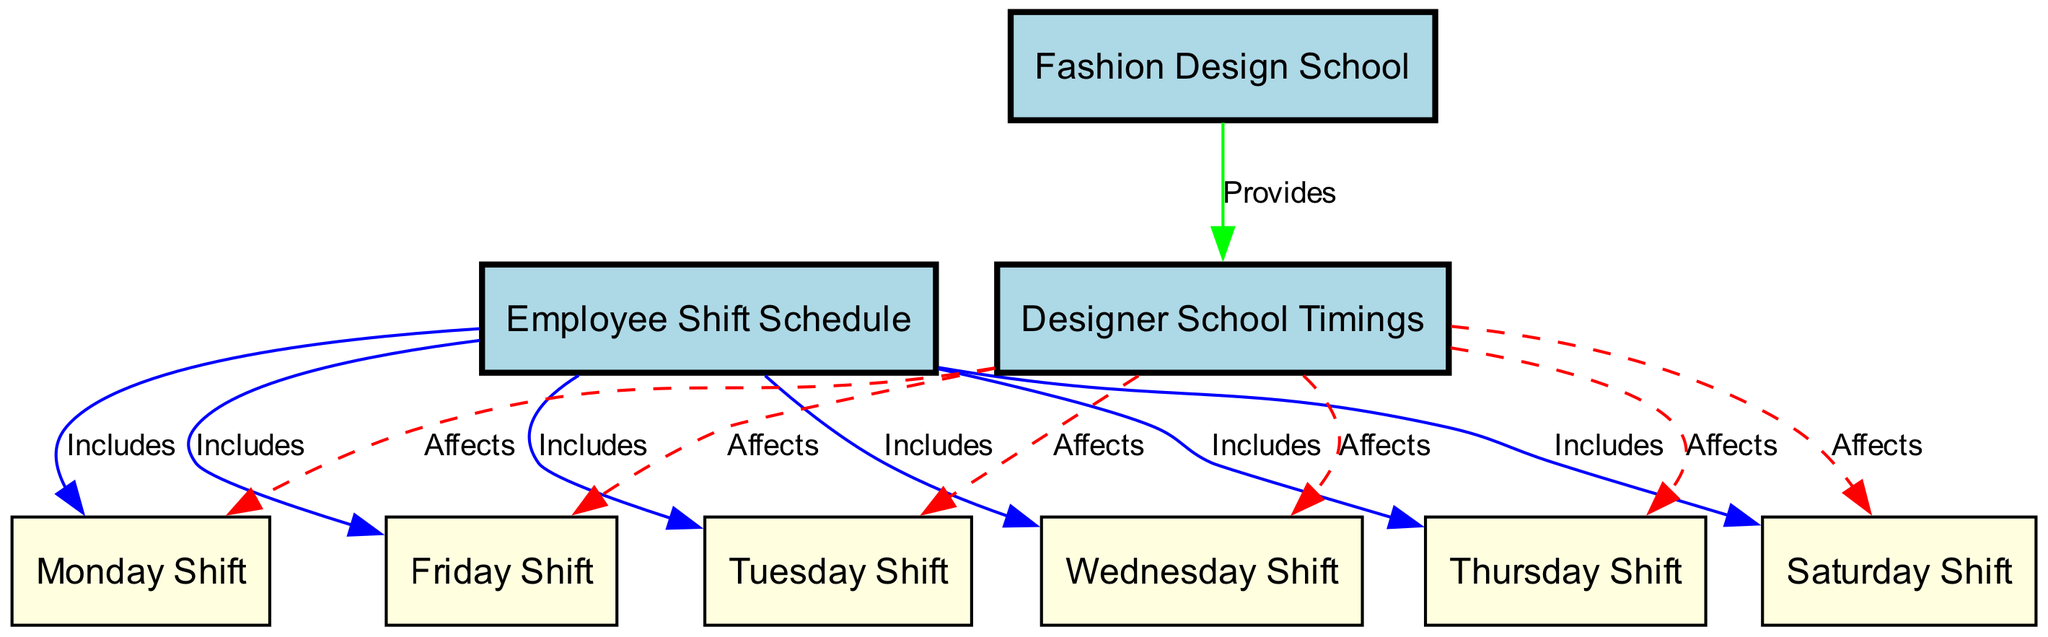What is the total number of nodes in the diagram? There are 10 nodes listed under the "elements" section of the data, including employee shift schedule, designer school timings, fashion design school, and the shifts for each day of the week.
Answer: 10 Which shifts are included in the employee shift schedule? The employee shift schedule includes Monday shift, Tuesday shift, Wednesday shift, Thursday shift, Friday shift, and Saturday shift, as indicated by the 'Includes' relationships.
Answer: Monday shift, Tuesday shift, Wednesday shift, Thursday shift, Friday shift, Saturday shift How many shifts are affected by designer school timings? Designer school timings affect all six shifts detailed in the diagram, which are the shifts for each day of the week from Monday through Saturday.
Answer: 6 What is the relationship between designer school timings and shifts? The relationship is that the designer school timings affect each of the shifts, as indicated by the dashed red edges pointing from designer school timings to each shift in the diagram.
Answer: Affects Which node provides the designer school timings? The node that provides the designer school timings is the fashion design school, as shown by the 'Provides' relationship connecting fashion design school to designer school timings.
Answer: Fashion design school 